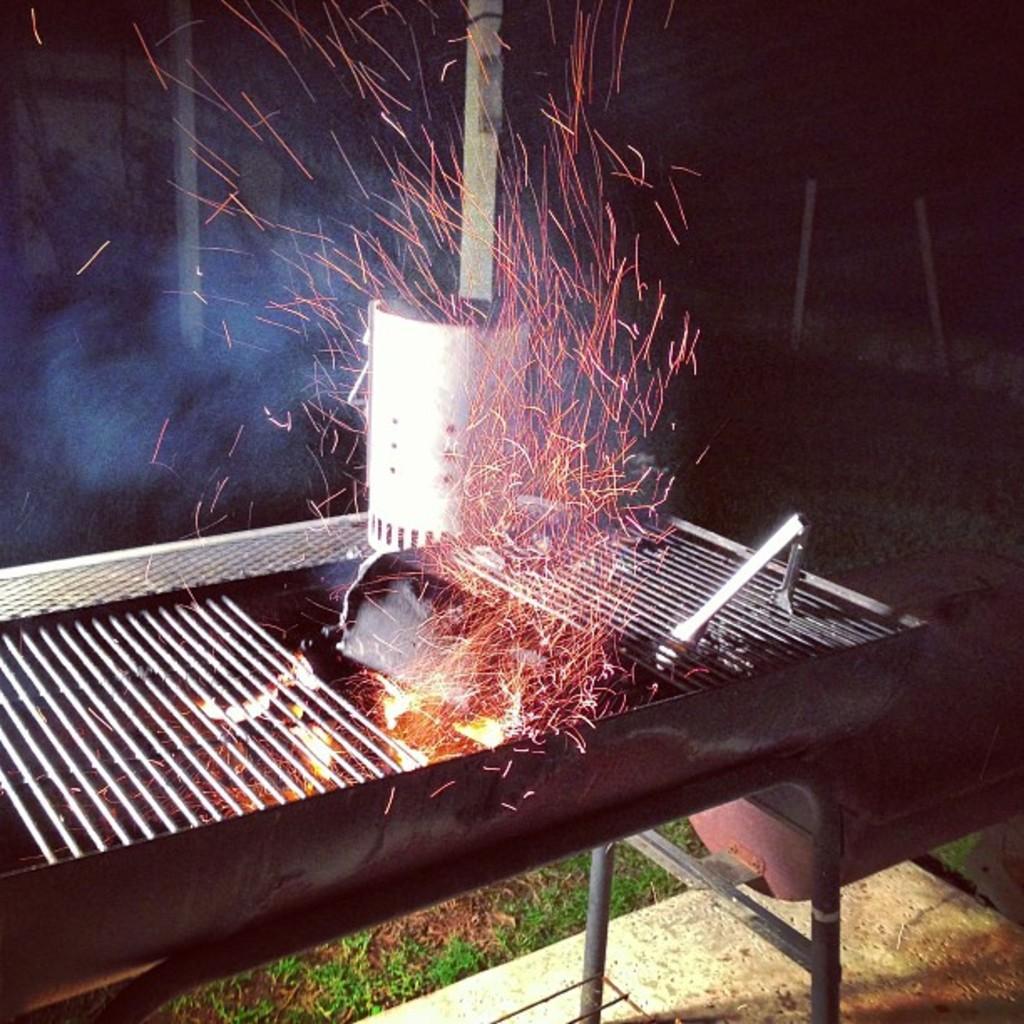In one or two sentences, can you explain what this image depicts? In this image, we can see a barbecue, flames, and tongs. At the bottom, we can see grass, rods and surface. Background it is dark. Here we can see poles and object. 